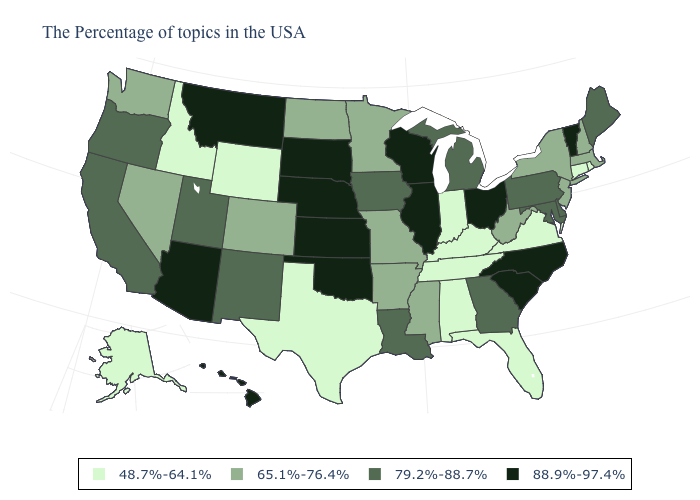What is the value of Alaska?
Short answer required. 48.7%-64.1%. Among the states that border Vermont , which have the highest value?
Write a very short answer. Massachusetts, New Hampshire, New York. Among the states that border Wisconsin , which have the lowest value?
Keep it brief. Minnesota. Does Louisiana have a lower value than Wisconsin?
Give a very brief answer. Yes. What is the lowest value in the USA?
Write a very short answer. 48.7%-64.1%. Name the states that have a value in the range 48.7%-64.1%?
Give a very brief answer. Rhode Island, Connecticut, Virginia, Florida, Kentucky, Indiana, Alabama, Tennessee, Texas, Wyoming, Idaho, Alaska. Does Alaska have the same value as North Carolina?
Keep it brief. No. Among the states that border South Dakota , which have the lowest value?
Concise answer only. Wyoming. Does Connecticut have the same value as Tennessee?
Concise answer only. Yes. Which states have the lowest value in the MidWest?
Keep it brief. Indiana. What is the highest value in states that border Vermont?
Answer briefly. 65.1%-76.4%. Is the legend a continuous bar?
Write a very short answer. No. Which states have the highest value in the USA?
Short answer required. Vermont, North Carolina, South Carolina, Ohio, Wisconsin, Illinois, Kansas, Nebraska, Oklahoma, South Dakota, Montana, Arizona, Hawaii. What is the lowest value in the USA?
Quick response, please. 48.7%-64.1%. Among the states that border New Hampshire , which have the lowest value?
Answer briefly. Massachusetts. 